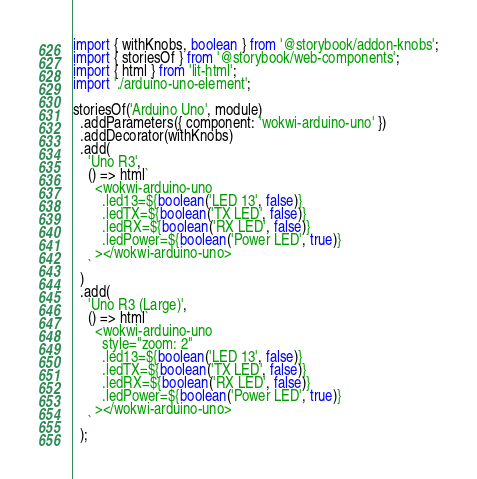Convert code to text. <code><loc_0><loc_0><loc_500><loc_500><_TypeScript_>import { withKnobs, boolean } from '@storybook/addon-knobs';
import { storiesOf } from '@storybook/web-components';
import { html } from 'lit-html';
import './arduino-uno-element';

storiesOf('Arduino Uno', module)
  .addParameters({ component: 'wokwi-arduino-uno' })
  .addDecorator(withKnobs)
  .add(
    'Uno R3',
    () => html`
      <wokwi-arduino-uno
        .led13=${boolean('LED 13', false)}
        .ledTX=${boolean('TX LED', false)}
        .ledRX=${boolean('RX LED', false)}
        .ledPower=${boolean('Power LED', true)}
      ></wokwi-arduino-uno>
    `
  )
  .add(
    'Uno R3 (Large)',
    () => html`
      <wokwi-arduino-uno
        style="zoom: 2"
        .led13=${boolean('LED 13', false)}
        .ledTX=${boolean('TX LED', false)}
        .ledRX=${boolean('RX LED', false)}
        .ledPower=${boolean('Power LED', true)}
      ></wokwi-arduino-uno>
    `
  );
</code> 